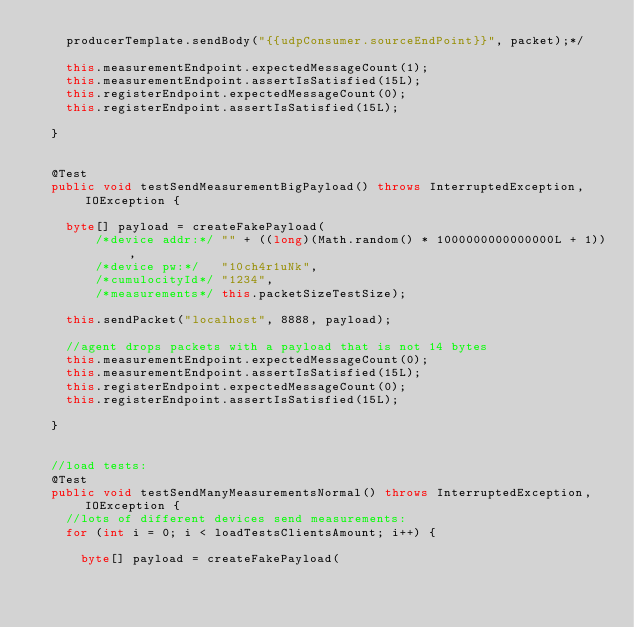Convert code to text. <code><loc_0><loc_0><loc_500><loc_500><_Java_>    producerTemplate.sendBody("{{udpConsumer.sourceEndPoint}}", packet);*/

    this.measurementEndpoint.expectedMessageCount(1);
    this.measurementEndpoint.assertIsSatisfied(15L);
    this.registerEndpoint.expectedMessageCount(0);
    this.registerEndpoint.assertIsSatisfied(15L);
    
  }
  

  @Test
  public void testSendMeasurementBigPayload() throws InterruptedException, IOException {
    
    byte[] payload = createFakePayload(
        /*device addr:*/ "" + ((long)(Math.random() * 1000000000000000L + 1)),
        /*device pw:*/   "10ch4r1uNk", 
        /*cumulocityId*/ "1234", 
        /*measurements*/ this.packetSizeTestSize);
    
    this.sendPacket("localhost", 8888, payload);

    //agent drops packets with a payload that is not 14 bytes
    this.measurementEndpoint.expectedMessageCount(0);
    this.measurementEndpoint.assertIsSatisfied(15L);
    this.registerEndpoint.expectedMessageCount(0);
    this.registerEndpoint.assertIsSatisfied(15L);
    
  }

  
  //load tests:
  @Test
  public void testSendManyMeasurementsNormal() throws InterruptedException, IOException {
    //lots of different devices send measurements:
    for (int i = 0; i < loadTestsClientsAmount; i++) {

      byte[] payload = createFakePayload(</code> 